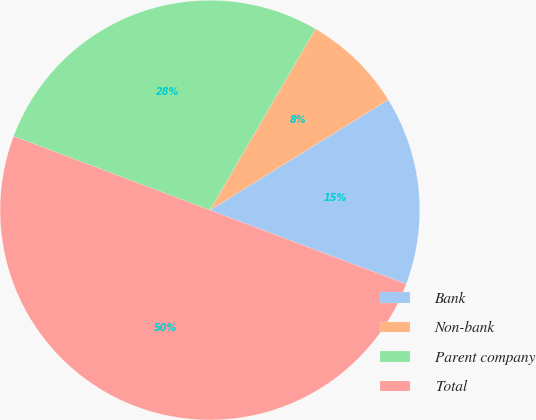Convert chart. <chart><loc_0><loc_0><loc_500><loc_500><pie_chart><fcel>Bank<fcel>Non-bank<fcel>Parent company<fcel>Total<nl><fcel>14.55%<fcel>7.79%<fcel>27.66%<fcel>50.0%<nl></chart> 